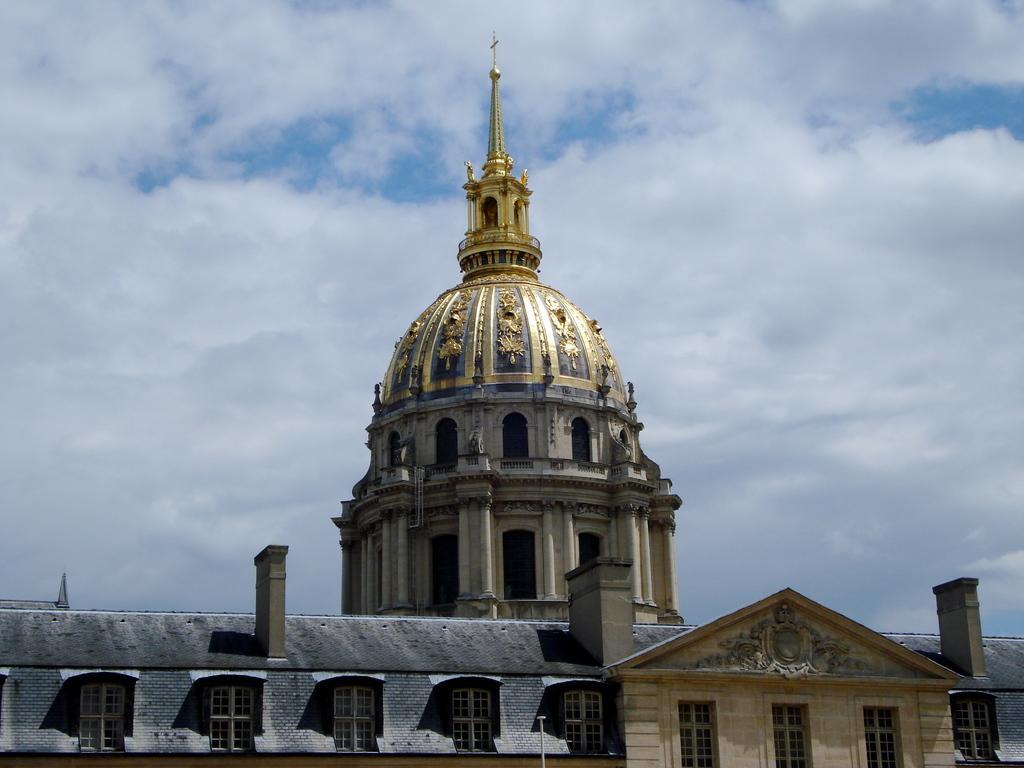Can you describe this image briefly? Here we can see ancient architecture. In the background there is sky with clouds. 